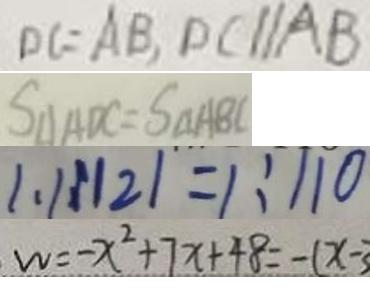<formula> <loc_0><loc_0><loc_500><loc_500>D C = A B , D C / / A B 
 S _ { \Delta } A D C = S _ { \Delta } A B C 
 1 . 1 : 1 2 1 = 1 : 1 1 0 
 w = - x ^ { 2 } + 7 x + 4 8 = - ( x - 3</formula> 